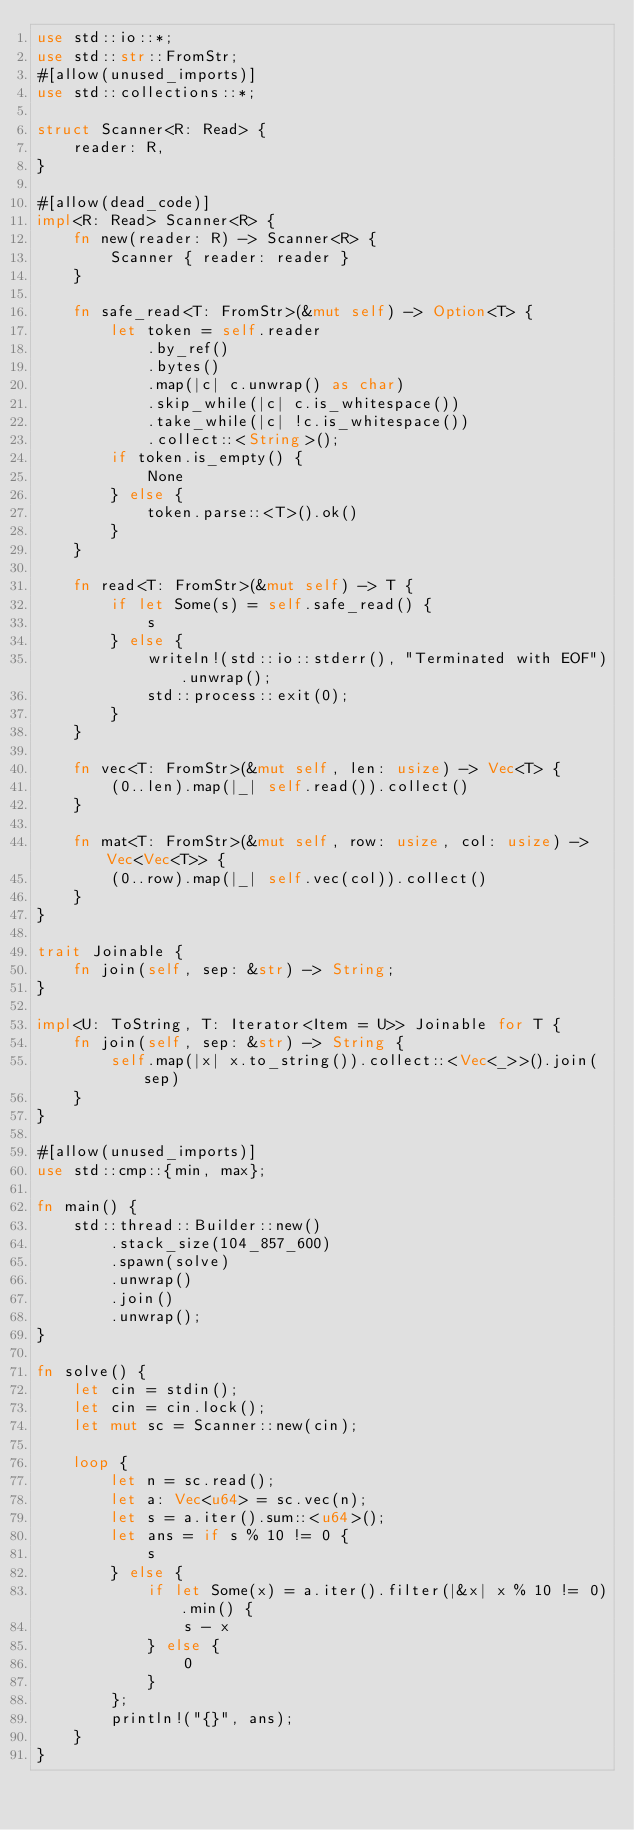<code> <loc_0><loc_0><loc_500><loc_500><_Rust_>use std::io::*;
use std::str::FromStr;
#[allow(unused_imports)]
use std::collections::*;

struct Scanner<R: Read> {
    reader: R,
}

#[allow(dead_code)]
impl<R: Read> Scanner<R> {
    fn new(reader: R) -> Scanner<R> {
        Scanner { reader: reader }
    }

    fn safe_read<T: FromStr>(&mut self) -> Option<T> {
        let token = self.reader
            .by_ref()
            .bytes()
            .map(|c| c.unwrap() as char)
            .skip_while(|c| c.is_whitespace())
            .take_while(|c| !c.is_whitespace())
            .collect::<String>();
        if token.is_empty() {
            None
        } else {
            token.parse::<T>().ok()
        }
    }

    fn read<T: FromStr>(&mut self) -> T {
        if let Some(s) = self.safe_read() {
            s
        } else {
            writeln!(std::io::stderr(), "Terminated with EOF").unwrap();
            std::process::exit(0);
        }
    }

    fn vec<T: FromStr>(&mut self, len: usize) -> Vec<T> {
        (0..len).map(|_| self.read()).collect()
    }

    fn mat<T: FromStr>(&mut self, row: usize, col: usize) -> Vec<Vec<T>> {
        (0..row).map(|_| self.vec(col)).collect()
    }
}

trait Joinable {
    fn join(self, sep: &str) -> String;
}

impl<U: ToString, T: Iterator<Item = U>> Joinable for T {
    fn join(self, sep: &str) -> String {
        self.map(|x| x.to_string()).collect::<Vec<_>>().join(sep)
    }
}

#[allow(unused_imports)]
use std::cmp::{min, max};

fn main() {
    std::thread::Builder::new()
        .stack_size(104_857_600)
        .spawn(solve)
        .unwrap()
        .join()
        .unwrap();
}

fn solve() {
    let cin = stdin();
    let cin = cin.lock();
    let mut sc = Scanner::new(cin);

    loop {
        let n = sc.read();
        let a: Vec<u64> = sc.vec(n);
        let s = a.iter().sum::<u64>();
        let ans = if s % 10 != 0 {
            s
        } else {
            if let Some(x) = a.iter().filter(|&x| x % 10 != 0).min() {
                s - x
            } else {
                0
            }
        };
        println!("{}", ans);
    }
}
</code> 